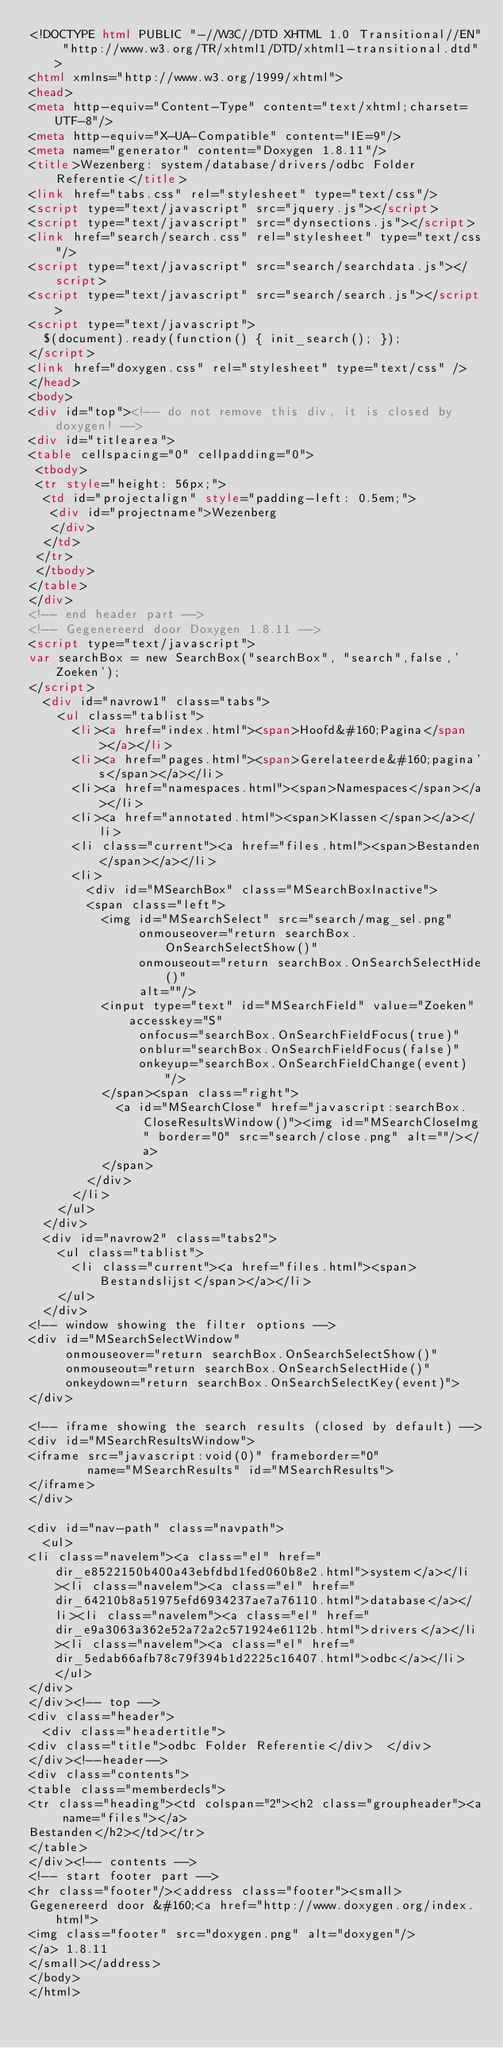Convert code to text. <code><loc_0><loc_0><loc_500><loc_500><_HTML_><!DOCTYPE html PUBLIC "-//W3C//DTD XHTML 1.0 Transitional//EN" "http://www.w3.org/TR/xhtml1/DTD/xhtml1-transitional.dtd">
<html xmlns="http://www.w3.org/1999/xhtml">
<head>
<meta http-equiv="Content-Type" content="text/xhtml;charset=UTF-8"/>
<meta http-equiv="X-UA-Compatible" content="IE=9"/>
<meta name="generator" content="Doxygen 1.8.11"/>
<title>Wezenberg: system/database/drivers/odbc Folder Referentie</title>
<link href="tabs.css" rel="stylesheet" type="text/css"/>
<script type="text/javascript" src="jquery.js"></script>
<script type="text/javascript" src="dynsections.js"></script>
<link href="search/search.css" rel="stylesheet" type="text/css"/>
<script type="text/javascript" src="search/searchdata.js"></script>
<script type="text/javascript" src="search/search.js"></script>
<script type="text/javascript">
  $(document).ready(function() { init_search(); });
</script>
<link href="doxygen.css" rel="stylesheet" type="text/css" />
</head>
<body>
<div id="top"><!-- do not remove this div, it is closed by doxygen! -->
<div id="titlearea">
<table cellspacing="0" cellpadding="0">
 <tbody>
 <tr style="height: 56px;">
  <td id="projectalign" style="padding-left: 0.5em;">
   <div id="projectname">Wezenberg
   </div>
  </td>
 </tr>
 </tbody>
</table>
</div>
<!-- end header part -->
<!-- Gegenereerd door Doxygen 1.8.11 -->
<script type="text/javascript">
var searchBox = new SearchBox("searchBox", "search",false,'Zoeken');
</script>
  <div id="navrow1" class="tabs">
    <ul class="tablist">
      <li><a href="index.html"><span>Hoofd&#160;Pagina</span></a></li>
      <li><a href="pages.html"><span>Gerelateerde&#160;pagina's</span></a></li>
      <li><a href="namespaces.html"><span>Namespaces</span></a></li>
      <li><a href="annotated.html"><span>Klassen</span></a></li>
      <li class="current"><a href="files.html"><span>Bestanden</span></a></li>
      <li>
        <div id="MSearchBox" class="MSearchBoxInactive">
        <span class="left">
          <img id="MSearchSelect" src="search/mag_sel.png"
               onmouseover="return searchBox.OnSearchSelectShow()"
               onmouseout="return searchBox.OnSearchSelectHide()"
               alt=""/>
          <input type="text" id="MSearchField" value="Zoeken" accesskey="S"
               onfocus="searchBox.OnSearchFieldFocus(true)" 
               onblur="searchBox.OnSearchFieldFocus(false)" 
               onkeyup="searchBox.OnSearchFieldChange(event)"/>
          </span><span class="right">
            <a id="MSearchClose" href="javascript:searchBox.CloseResultsWindow()"><img id="MSearchCloseImg" border="0" src="search/close.png" alt=""/></a>
          </span>
        </div>
      </li>
    </ul>
  </div>
  <div id="navrow2" class="tabs2">
    <ul class="tablist">
      <li class="current"><a href="files.html"><span>Bestandslijst</span></a></li>
    </ul>
  </div>
<!-- window showing the filter options -->
<div id="MSearchSelectWindow"
     onmouseover="return searchBox.OnSearchSelectShow()"
     onmouseout="return searchBox.OnSearchSelectHide()"
     onkeydown="return searchBox.OnSearchSelectKey(event)">
</div>

<!-- iframe showing the search results (closed by default) -->
<div id="MSearchResultsWindow">
<iframe src="javascript:void(0)" frameborder="0" 
        name="MSearchResults" id="MSearchResults">
</iframe>
</div>

<div id="nav-path" class="navpath">
  <ul>
<li class="navelem"><a class="el" href="dir_e8522150b400a43ebfdbd1fed060b8e2.html">system</a></li><li class="navelem"><a class="el" href="dir_64210b8a51975efd6934237ae7a76110.html">database</a></li><li class="navelem"><a class="el" href="dir_e9a3063a362e52a72a2c571924e6112b.html">drivers</a></li><li class="navelem"><a class="el" href="dir_5edab66afb78c79f394b1d2225c16407.html">odbc</a></li>  </ul>
</div>
</div><!-- top -->
<div class="header">
  <div class="headertitle">
<div class="title">odbc Folder Referentie</div>  </div>
</div><!--header-->
<div class="contents">
<table class="memberdecls">
<tr class="heading"><td colspan="2"><h2 class="groupheader"><a name="files"></a>
Bestanden</h2></td></tr>
</table>
</div><!-- contents -->
<!-- start footer part -->
<hr class="footer"/><address class="footer"><small>
Gegenereerd door &#160;<a href="http://www.doxygen.org/index.html">
<img class="footer" src="doxygen.png" alt="doxygen"/>
</a> 1.8.11
</small></address>
</body>
</html>
</code> 